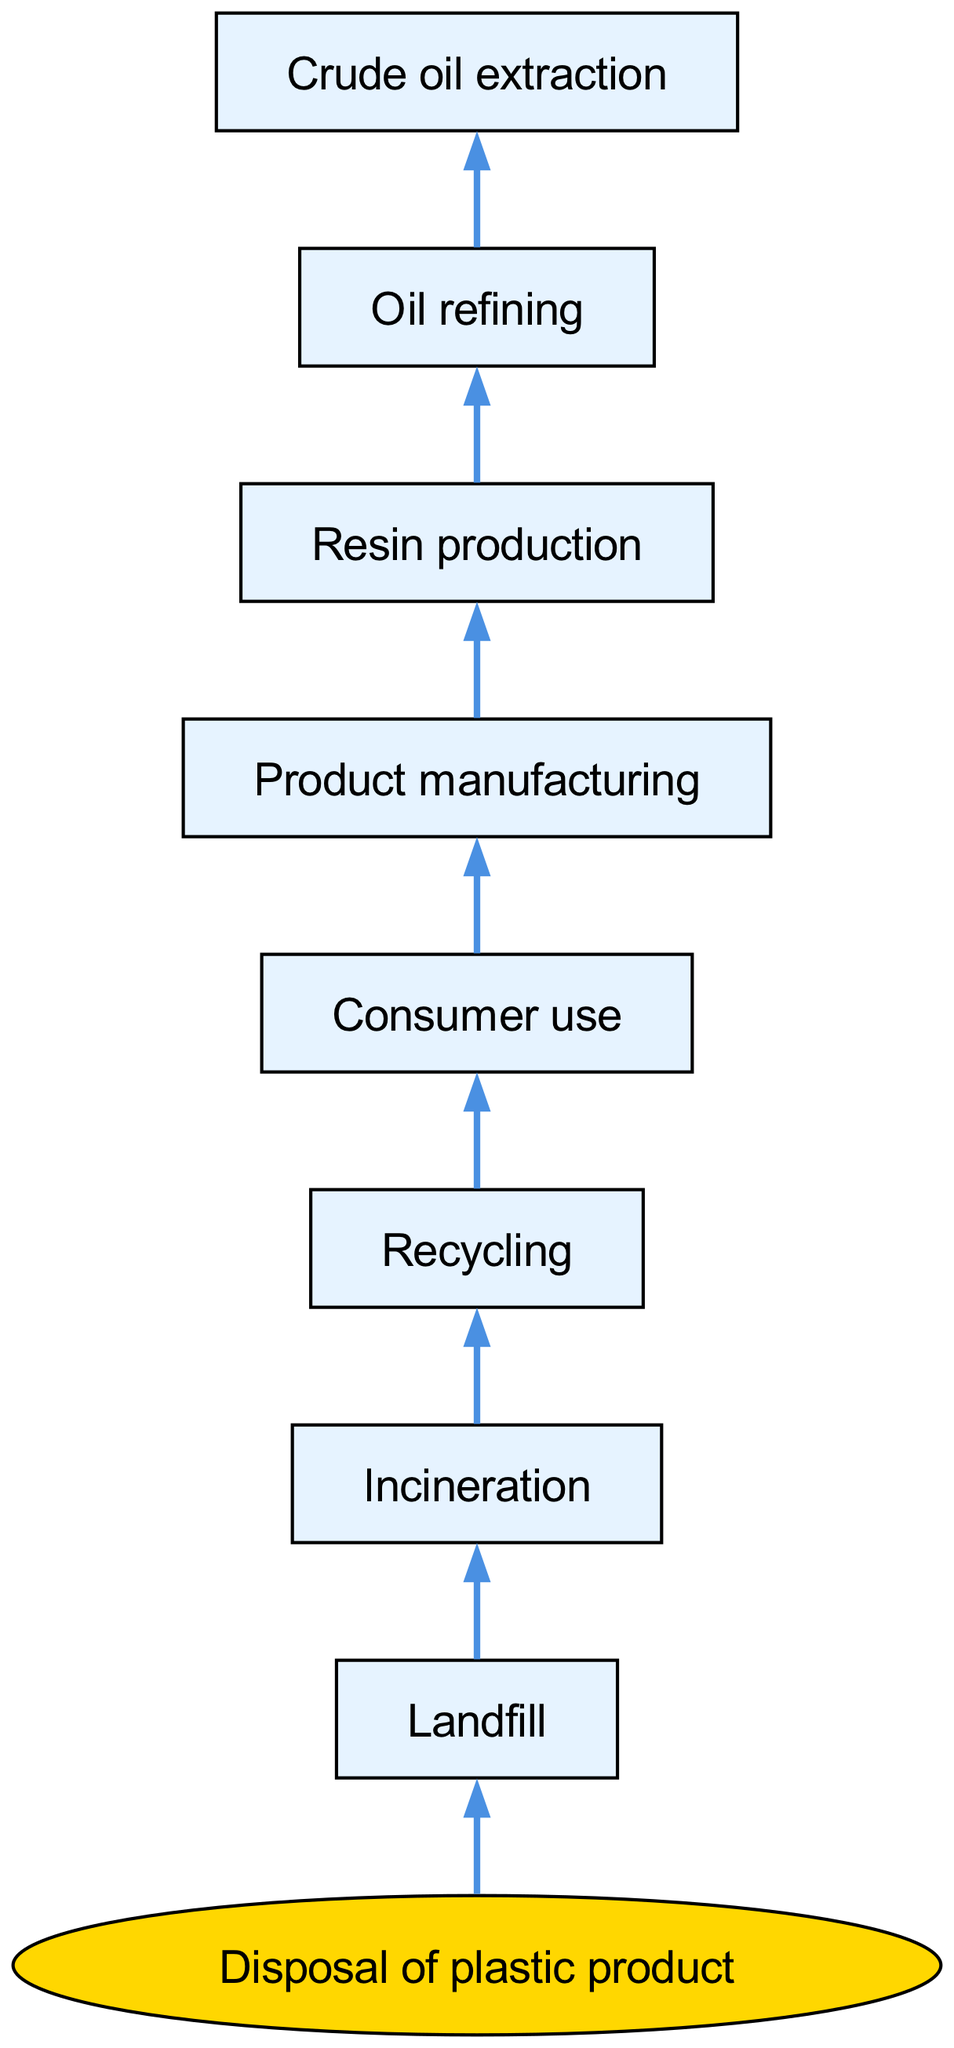What is the starting point of the flow chart? The flow chart starts with the node labeled "Disposal of plastic product." This is the top-most element in the structure and serves as the origin from which all subsequent processes branch out.
Answer: Disposal of plastic product How many main branches are there in the flow chart? There is one main branch extending from the starting point, which is "Landfill." This branch contains various subsequent nodes connected to it.
Answer: 1 What is the last process before consumer use? The last process before consumer use in the diagram is "Recycling." This node directly follows "Incineration" and leads to "Consumer use."
Answer: Recycling Which node comes directly after oil refining? The node that comes directly after "Oil refining" is "Resin production." This relationship indicates that resin production is the next step after oil refining in the flow chart.
Answer: Resin production How many nodes are there in total within the flow chart? A total of 10 nodes exist within the flow chart. This includes the starting node and all subsequent nodes connected in the hierarchy.
Answer: 10 What follows directly after consumer use? The step that follows directly after "Consumer use" is "Product manufacturing." This shows that product manufacturing occurs after consumers utilize the product.
Answer: Product manufacturing What is the final disposal method illustrated in the flow chart? The final disposal method illustrated in the flow chart is "Incineration," which is a method of dealing with plastic waste before possibly heading into recycling or landfill.
Answer: Incineration How do "Crude oil extraction" and "Resin production" relate in the flow chart? "Crude oil extraction" is the initial step leading to "Oil refining," which then leads to "Resin production." This indicates a sequential process where the first step directly affects the next, eventually leading to resin production.
Answer: Sequential process 